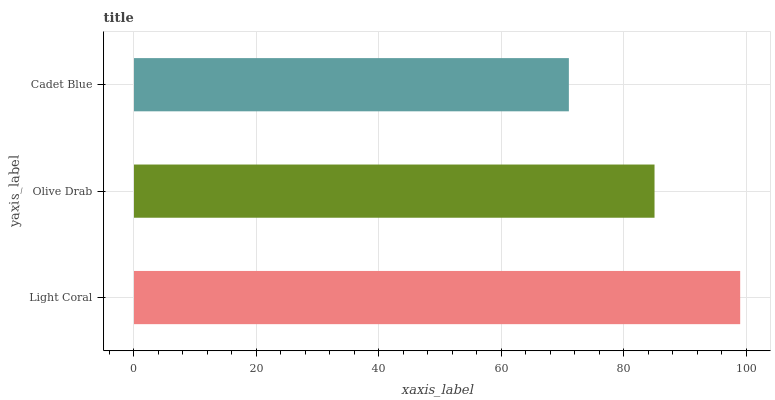Is Cadet Blue the minimum?
Answer yes or no. Yes. Is Light Coral the maximum?
Answer yes or no. Yes. Is Olive Drab the minimum?
Answer yes or no. No. Is Olive Drab the maximum?
Answer yes or no. No. Is Light Coral greater than Olive Drab?
Answer yes or no. Yes. Is Olive Drab less than Light Coral?
Answer yes or no. Yes. Is Olive Drab greater than Light Coral?
Answer yes or no. No. Is Light Coral less than Olive Drab?
Answer yes or no. No. Is Olive Drab the high median?
Answer yes or no. Yes. Is Olive Drab the low median?
Answer yes or no. Yes. Is Cadet Blue the high median?
Answer yes or no. No. Is Light Coral the low median?
Answer yes or no. No. 